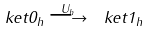<formula> <loc_0><loc_0><loc_500><loc_500>\ k e t { 0 } _ { h } \stackrel { U _ { h } } { \longrightarrow } \ k e t { 1 } _ { h }</formula> 